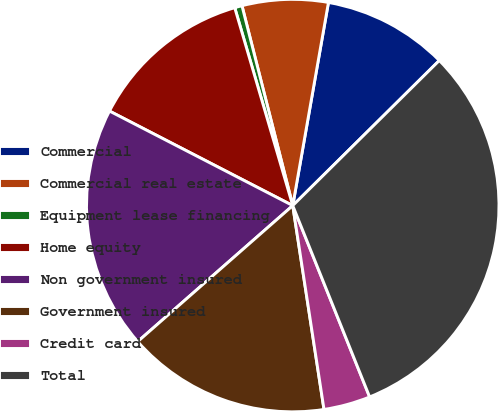Convert chart. <chart><loc_0><loc_0><loc_500><loc_500><pie_chart><fcel>Commercial<fcel>Commercial real estate<fcel>Equipment lease financing<fcel>Home equity<fcel>Non government insured<fcel>Government insured<fcel>Credit card<fcel>Total<nl><fcel>9.81%<fcel>6.73%<fcel>0.58%<fcel>12.88%<fcel>19.04%<fcel>15.96%<fcel>3.66%<fcel>31.34%<nl></chart> 